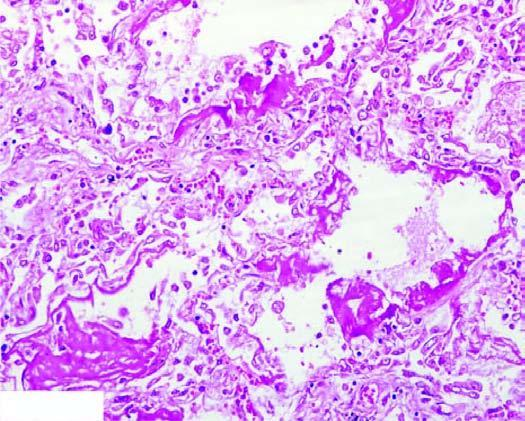what are there?
Answer the question using a single word or phrase. Alternate areas of collapsed and dilated alveolar spaces 